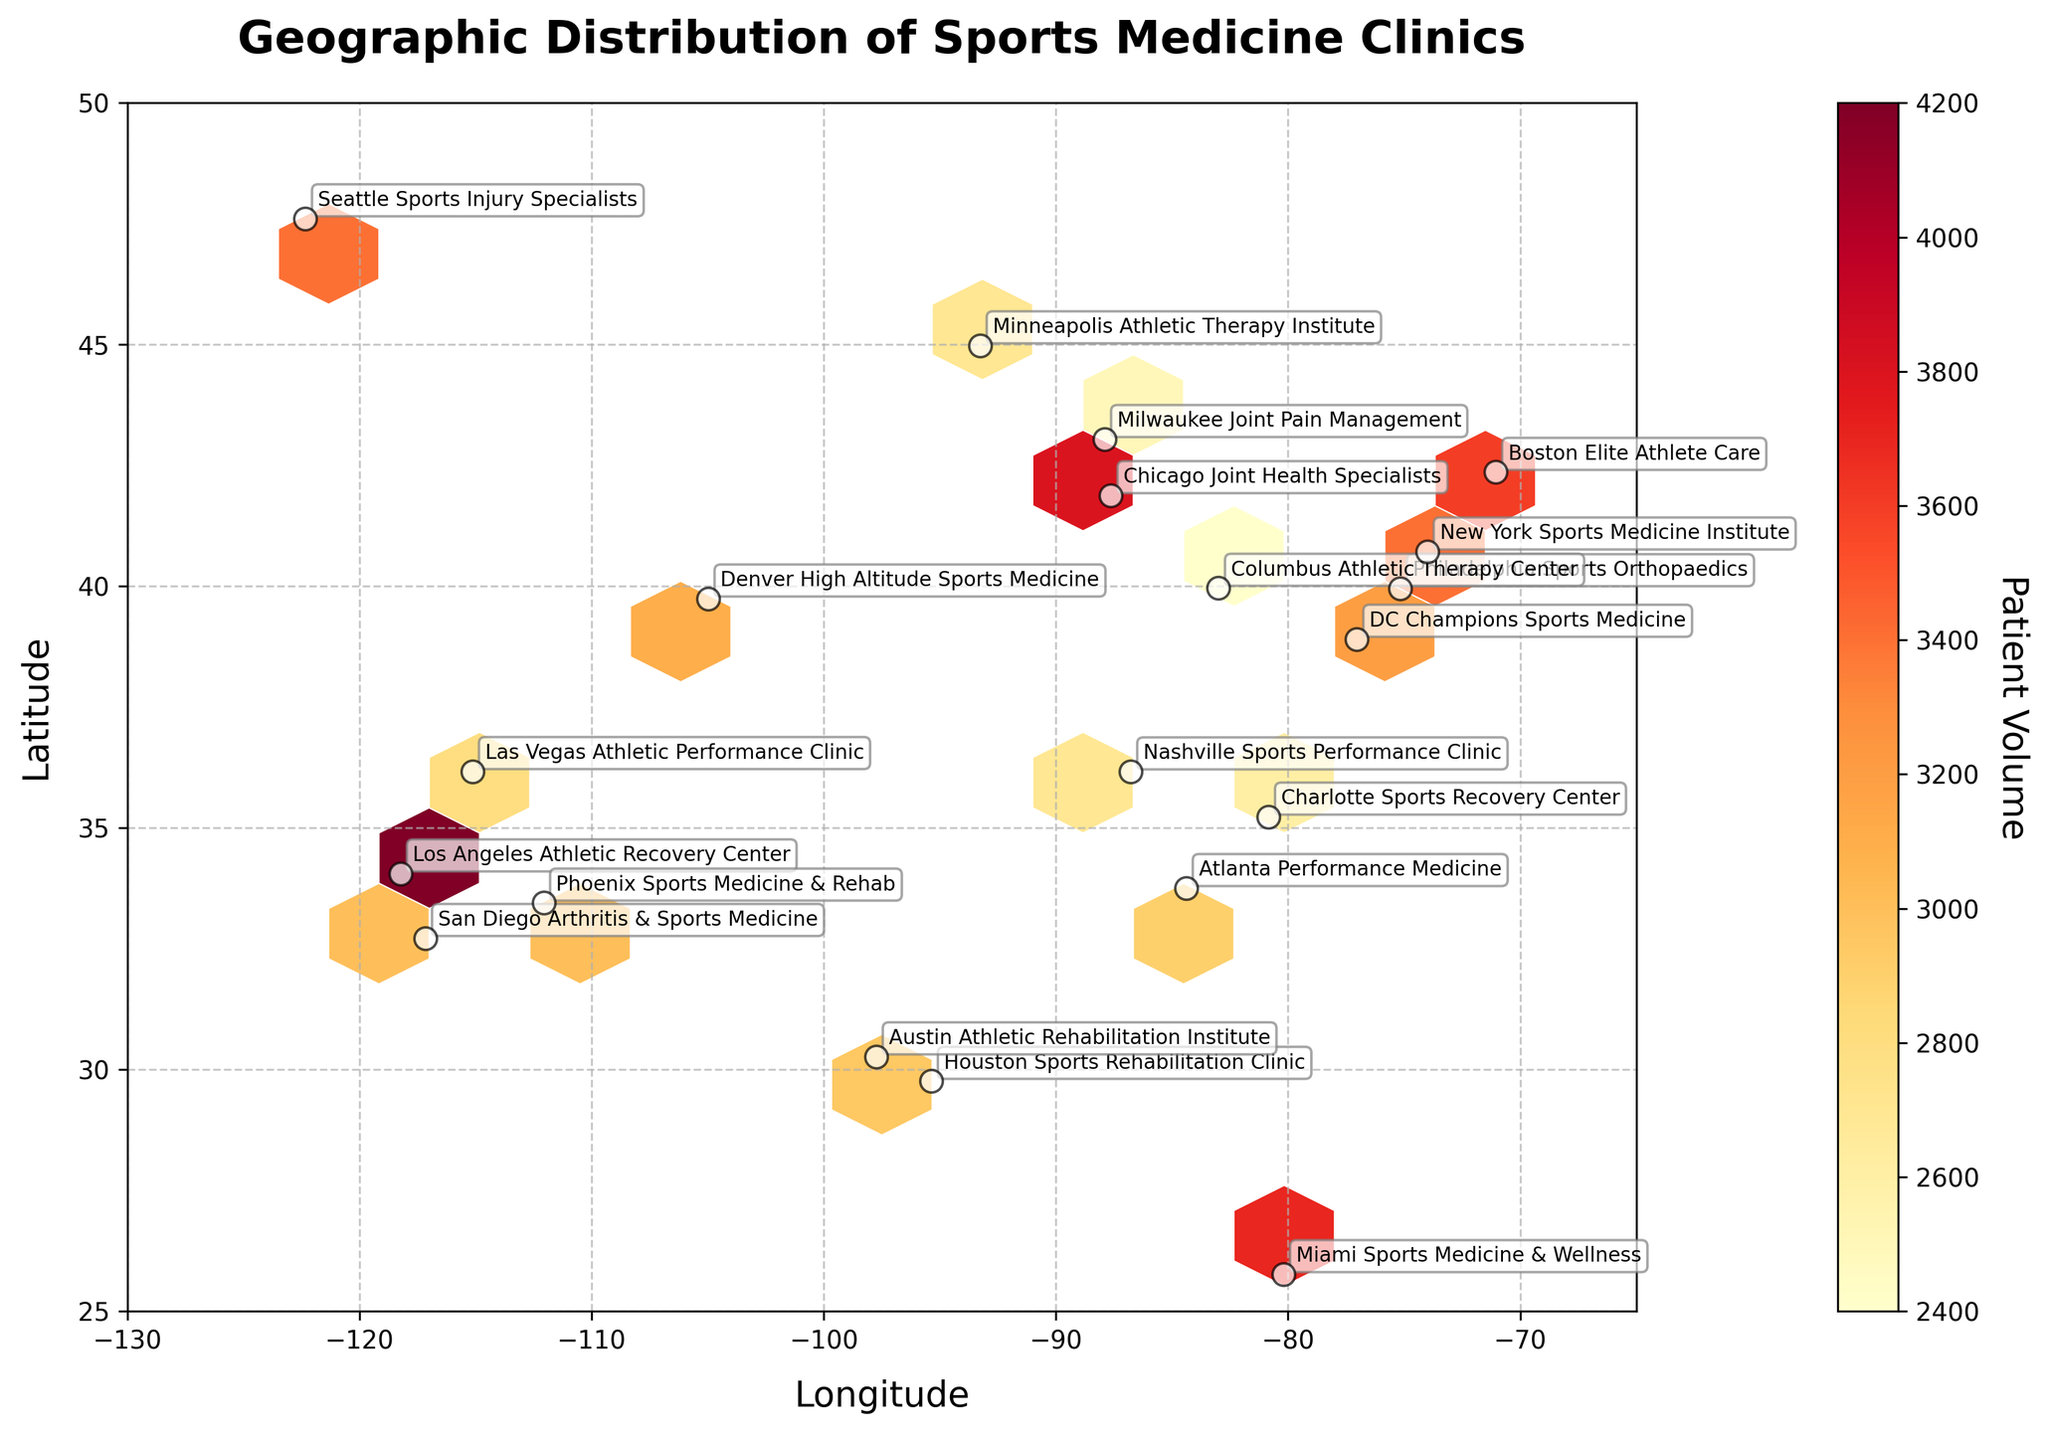What is the title of the plot? The title of the plot is written at the top of the figure and reads "Geographic Distribution of Sports Medicine Clinics."
Answer: Geographic Distribution of Sports Medicine Clinics What are the labels for the X and Y axes? The X-axis is labeled 'Longitude' and the Y-axis is labeled 'Latitude.'
Answer: Longitude and Latitude Which coordinate has the highest patient volume according to the color intensity? The hexbin with the darkest shade (representing the highest patient volume) is located around the coordinates of Los Angeles, which lies at approximately (34.0522, -118.2437).
Answer: Los Angeles How many clinics have a patient volume higher than 3000? By looking at the annotations and correlating with patient volume colors in the hexbin plot, the clinics with volumes higher than 3000 are: New York, Los Angeles, Chicago, Philadelphia, Boston, Seattle, Miami. There are 7 such clinics.
Answer: 7 What is the approximate geographic distribution range shown in the plot? The figure shows clinics distributed across the United States within the longitude range of -130 to -65 and the latitude range of 25 to 50.
Answer: Longitude: -130 to -65, Latitude: 25 to 50 Which clinic has the lowest patient volume, and where is it located? From the annotations in the hexbin plot, Milwaukee Joint Pain Management has the lowest patient volume at 2500, located in Milwaukee.
Answer: Milwaukee Joint Pain Management in Milwaukee What is the difference in patient volume between the clinic in New York and the clinic in Austin? New York Sports Medicine Institute has 3500 patients, and Austin Athletic Rehabilitation Institute has 2800 patients. The difference is 3500 - 2800 = 700.
Answer: 700 Which city has a clinic with a patient volume of 3200? According to the annotations and tabs shown in the plot, the clinic in Washington DC (DC Champions Sports Medicine) has a patient volume of 3200.
Answer: Washington DC How do clinics along the West Coast compare in terms of patient volume to clinics along the East Coast? West Coast cities like Los Angeles (4200), San Diego (3000), and Seattle (3400) have generally higher or similar patient volumes compared to East Coast clinics such as New York (3500), Philadelphia (3300), and Miami (3700), with the notable exception of Los Angeles having the highest volume overall.
Answer: West Coast clinics generally have higher or similar volumes What is the average patient volume among all the clinics listed? To find the average patient volume, sum all the patient volumes and divide it by the number of clinics. Sum: 3500 + 4200 + 3800 + 3100 + 2900 + 3300 + 3600 + 3000 + 2700 + 3200 + 2800 + 3400 + 3100 + 2600 + 2800 + 2500 + 3000 + 2700 + 2400 + 3700 = 61700. Number of clinics: 20. Average = 61700 / 20 = 3085.
Answer: 3085 